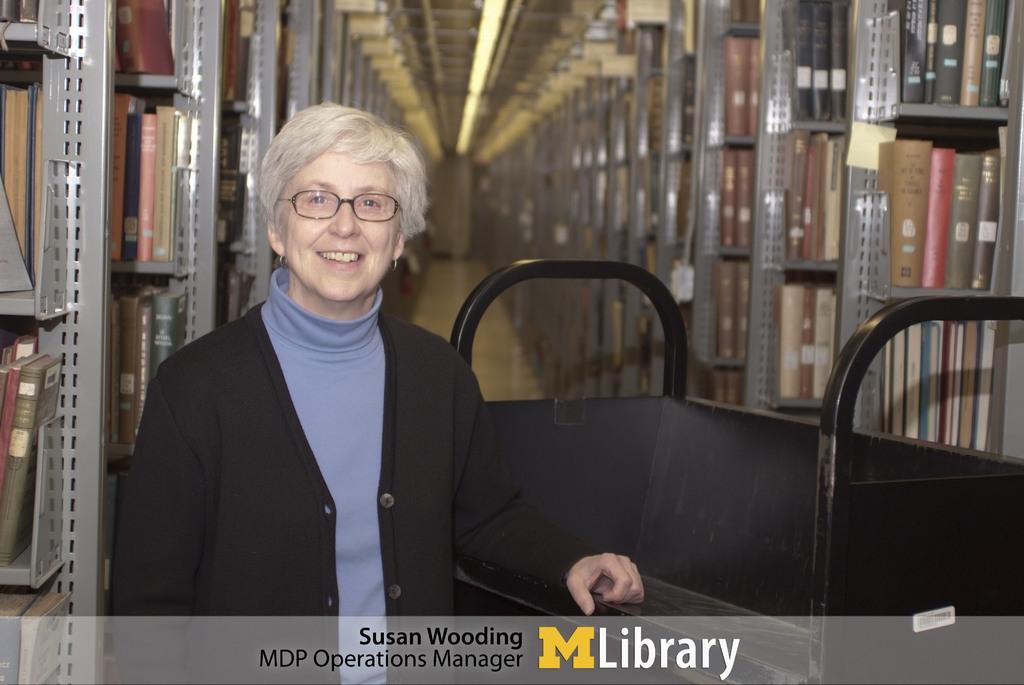In one or two sentences, can you explain what this image depicts? In the front of the image there is a black object and person. In the background of the image there are racks, books and lights. At the bottom of the image there is a watermark. 